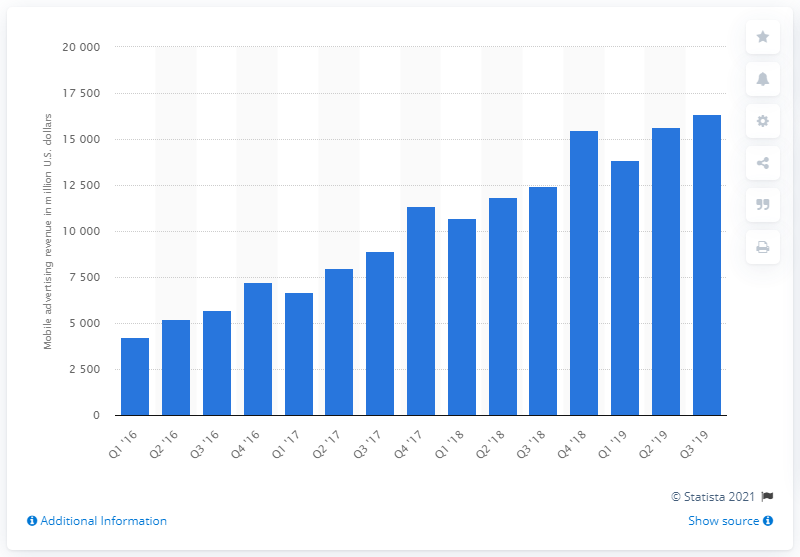Mention a couple of crucial points in this snapshot. Facebook's mobile ad revenue in the third quarter of 2019 was approximately 16,340. 